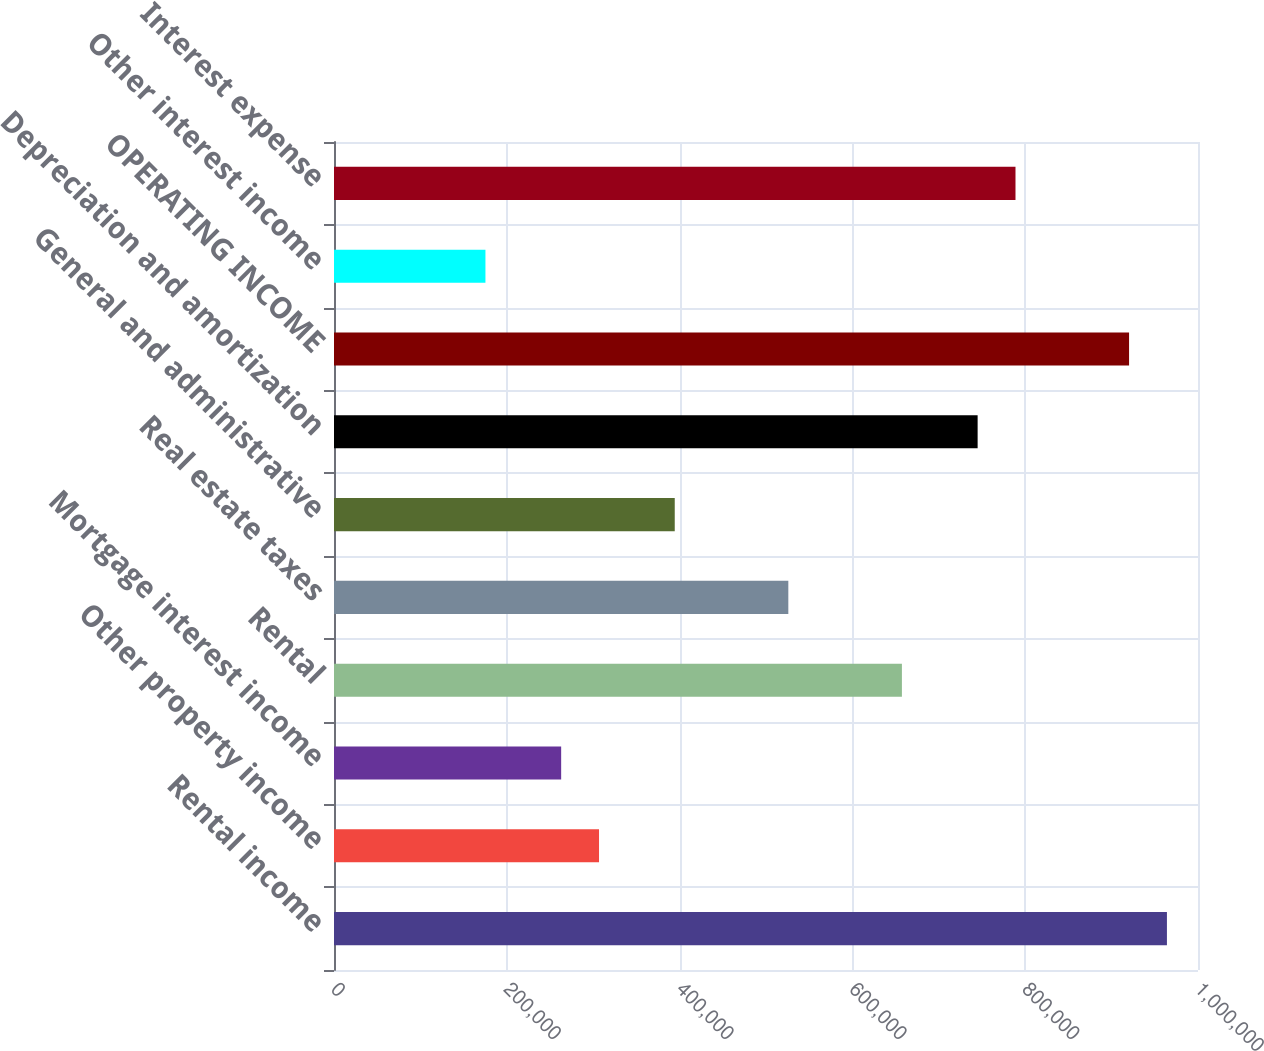Convert chart to OTSL. <chart><loc_0><loc_0><loc_500><loc_500><bar_chart><fcel>Rental income<fcel>Other property income<fcel>Mortgage interest income<fcel>Rental<fcel>Real estate taxes<fcel>General and administrative<fcel>Depreciation and amortization<fcel>OPERATING INCOME<fcel>Other interest income<fcel>Interest expense<nl><fcel>964042<fcel>306741<fcel>262921<fcel>657301<fcel>525841<fcel>394381<fcel>744941<fcel>920222<fcel>175281<fcel>788761<nl></chart> 